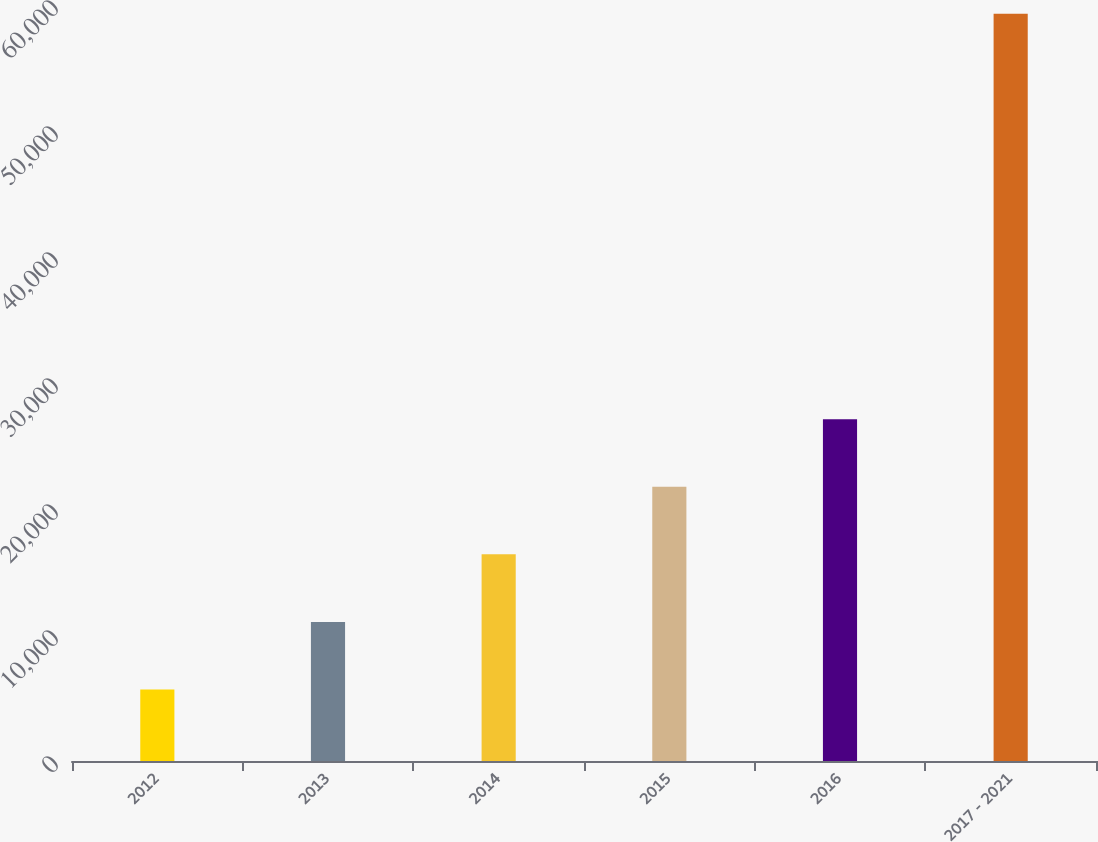Convert chart. <chart><loc_0><loc_0><loc_500><loc_500><bar_chart><fcel>2012<fcel>2013<fcel>2014<fcel>2015<fcel>2016<fcel>2017 - 2021<nl><fcel>5678<fcel>11040.8<fcel>16403.6<fcel>21766.4<fcel>27129.2<fcel>59306<nl></chart> 